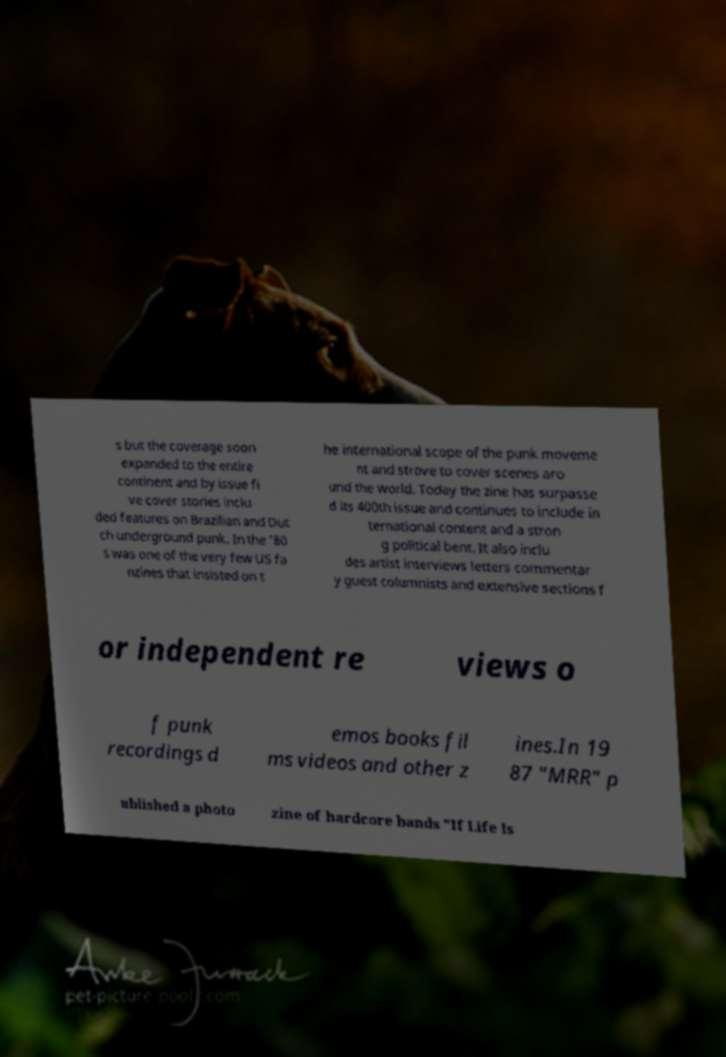Please identify and transcribe the text found in this image. s but the coverage soon expanded to the entire continent and by issue fi ve cover stories inclu ded features on Brazilian and Dut ch underground punk. In the '80 s was one of the very few US fa nzines that insisted on t he international scope of the punk moveme nt and strove to cover scenes aro und the world. Today the zine has surpasse d its 400th issue and continues to include in ternational content and a stron g political bent. It also inclu des artist interviews letters commentar y guest columnists and extensive sections f or independent re views o f punk recordings d emos books fil ms videos and other z ines.In 19 87 "MRR" p ublished a photo zine of hardcore bands "If Life Is 